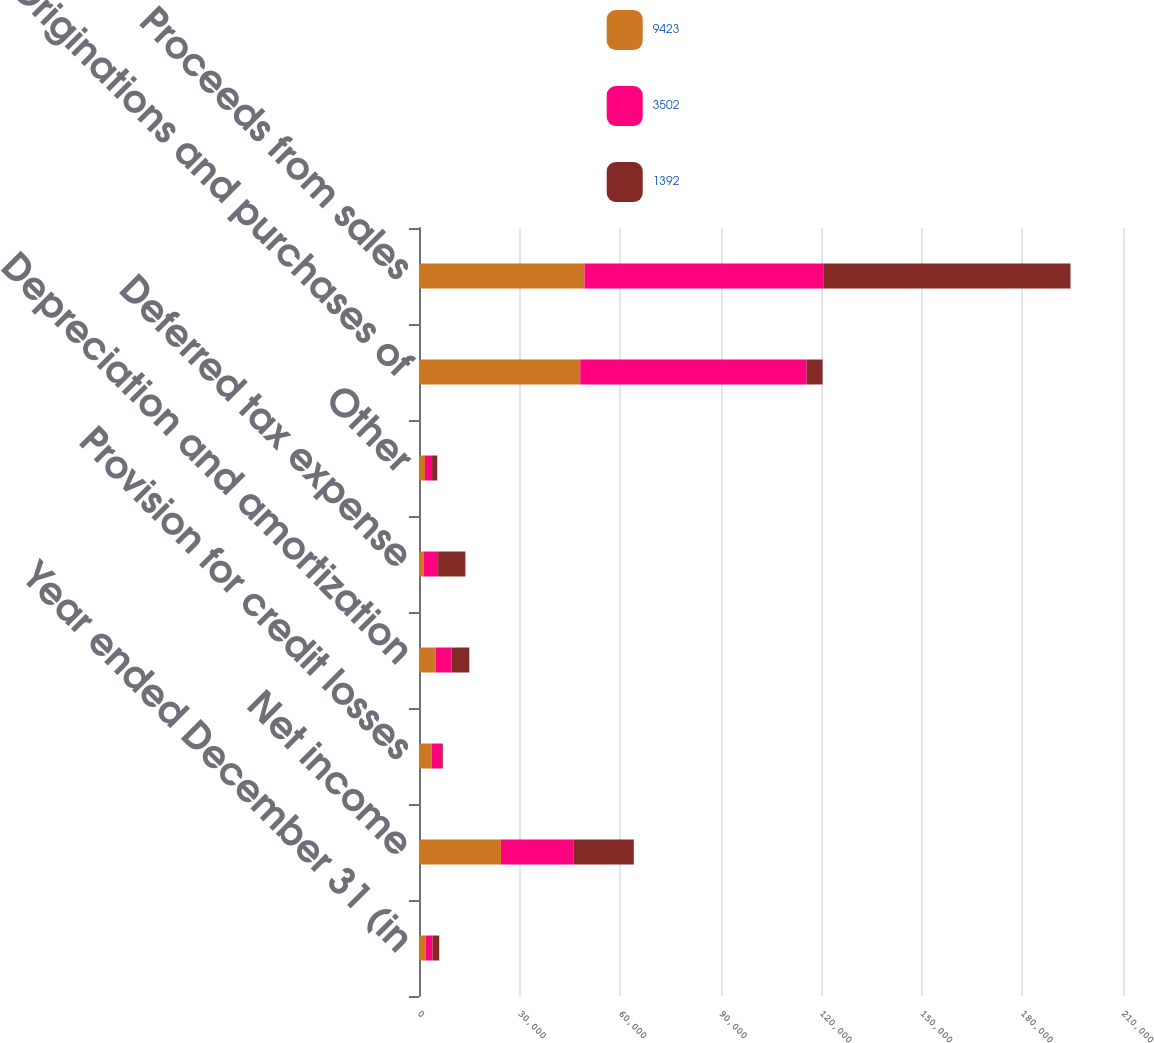Convert chart to OTSL. <chart><loc_0><loc_0><loc_500><loc_500><stacked_bar_chart><ecel><fcel>Year ended December 31 (in<fcel>Net income<fcel>Provision for credit losses<fcel>Depreciation and amortization<fcel>Deferred tax expense<fcel>Other<fcel>Originations and purchases of<fcel>Proceeds from sales<nl><fcel>9423<fcel>2015<fcel>24442<fcel>3827<fcel>4940<fcel>1333<fcel>1785<fcel>48109<fcel>49363<nl><fcel>3502<fcel>2014<fcel>21745<fcel>3139<fcel>4759<fcel>4362<fcel>2113<fcel>67525<fcel>71407<nl><fcel>1392<fcel>2013<fcel>17886<fcel>225<fcel>5306<fcel>8139<fcel>1552<fcel>4759<fcel>73566<nl></chart> 